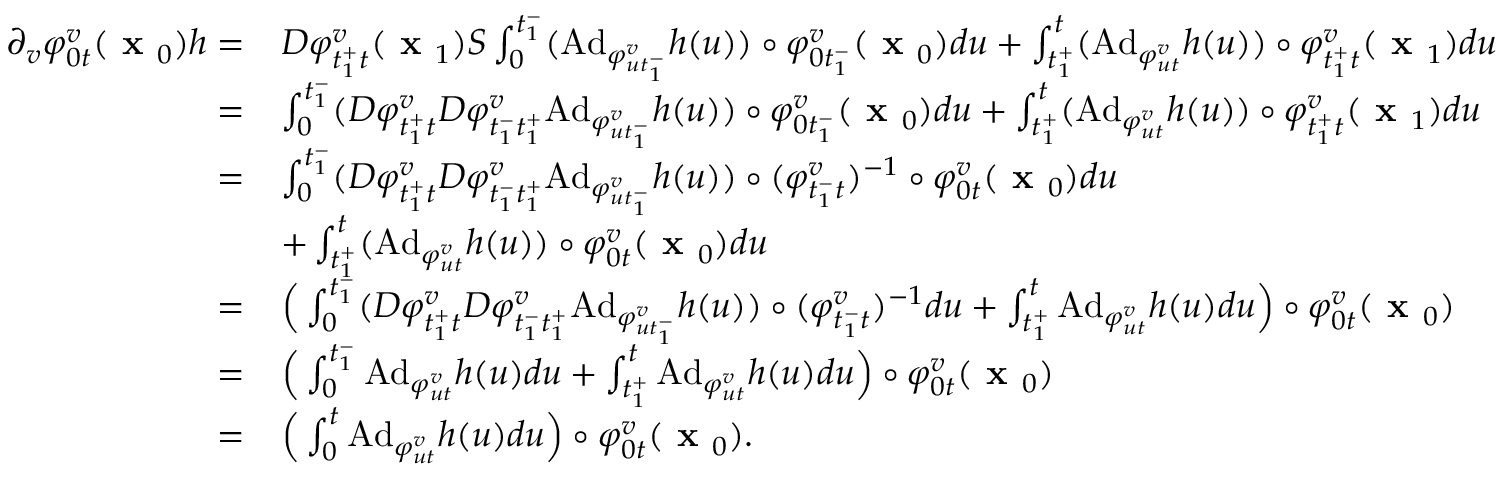Convert formula to latex. <formula><loc_0><loc_0><loc_500><loc_500>\begin{array} { r l } { \partial _ { v } \varphi _ { 0 t } ^ { v } ( x _ { 0 } ) h = } & { D \varphi _ { t _ { 1 } ^ { + } t } ^ { v } ( x _ { 1 } ) S \int _ { 0 } ^ { t _ { 1 } ^ { - } } ( A d _ { \varphi _ { u t _ { 1 } ^ { - } } ^ { v } } h ( u ) ) \circ \varphi _ { 0 t _ { 1 } ^ { - } } ^ { v } ( x _ { 0 } ) d u + \int _ { t _ { 1 } ^ { + } } ^ { t } ( A d _ { \varphi _ { u t } ^ { v } } h ( u ) ) \circ \varphi _ { t _ { 1 } ^ { + } t } ^ { v } ( x _ { 1 } ) d u } \\ { = } & { \int _ { 0 } ^ { t _ { 1 } ^ { - } } ( D \varphi _ { t _ { 1 } ^ { + } t } ^ { v } D \varphi _ { t _ { 1 } ^ { - } t _ { 1 } ^ { + } } ^ { v } A d _ { \varphi _ { u t _ { 1 } ^ { - } } ^ { v } } h ( u ) ) \circ \varphi _ { 0 t _ { 1 } ^ { - } } ^ { v } ( x _ { 0 } ) d u + \int _ { t _ { 1 } ^ { + } } ^ { t } ( A d _ { \varphi _ { u t } ^ { v } } h ( u ) ) \circ \varphi _ { t _ { 1 } ^ { + } t } ^ { v } ( x _ { 1 } ) d u } \\ { = } & { \int _ { 0 } ^ { t _ { 1 } ^ { - } } ( D \varphi _ { t _ { 1 } ^ { + } t } ^ { v } D \varphi _ { t _ { 1 } ^ { - } t _ { 1 } ^ { + } } ^ { v } A d _ { \varphi _ { u t _ { 1 } ^ { - } } ^ { v } } h ( u ) ) \circ ( \varphi _ { t _ { 1 } ^ { - } t } ^ { v } ) ^ { - 1 } \circ \varphi _ { 0 t } ^ { v } ( x _ { 0 } ) d u } \\ & { + \int _ { t _ { 1 } ^ { + } } ^ { t } ( A d _ { \varphi _ { u t } ^ { v } } h ( u ) ) \circ \varphi _ { 0 t } ^ { v } ( x _ { 0 } ) d u } \\ { = } & { \left ( \int _ { 0 } ^ { t _ { 1 } ^ { - } } ( D \varphi _ { t _ { 1 } ^ { + } t } ^ { v } D \varphi _ { t _ { 1 } ^ { - } t _ { 1 } ^ { + } } ^ { v } A d _ { \varphi _ { u t _ { 1 } ^ { - } } ^ { v } } h ( u ) ) \circ ( \varphi _ { t _ { 1 } ^ { - } t } ^ { v } ) ^ { - 1 } d u + \int _ { t _ { 1 } ^ { + } } ^ { t } A d _ { \varphi _ { u t } ^ { v } } h ( u ) d u \right ) \circ \varphi _ { 0 t } ^ { v } ( x _ { 0 } ) } \\ { = } & { \left ( \int _ { 0 } ^ { t _ { 1 } ^ { - } } A d _ { \varphi _ { u t } ^ { v } } h ( u ) d u + \int _ { t _ { 1 } ^ { + } } ^ { t } A d _ { \varphi _ { u t } ^ { v } } h ( u ) d u \right ) \circ \varphi _ { 0 t } ^ { v } ( x _ { 0 } ) } \\ { = } & { \left ( \int _ { 0 } ^ { t } A d _ { \varphi _ { u t } ^ { v } } h ( u ) d u \right ) \circ \varphi _ { 0 t } ^ { v } ( x _ { 0 } ) . } \end{array}</formula> 